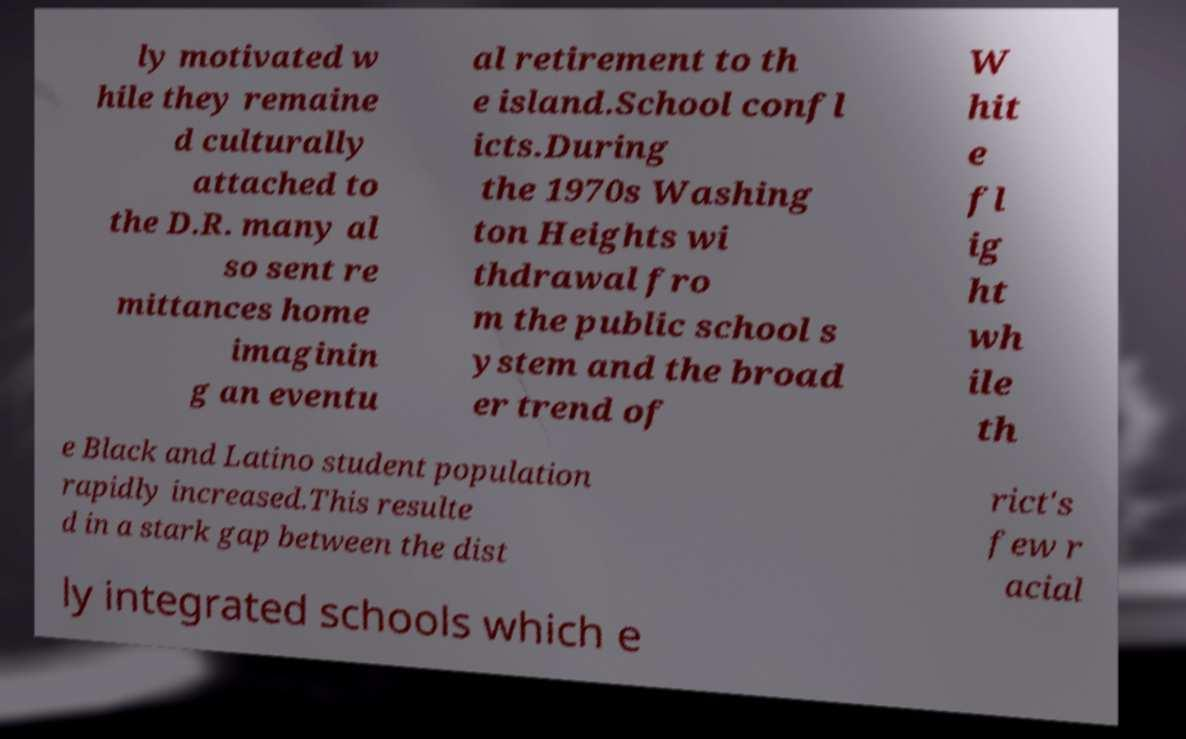There's text embedded in this image that I need extracted. Can you transcribe it verbatim? ly motivated w hile they remaine d culturally attached to the D.R. many al so sent re mittances home imaginin g an eventu al retirement to th e island.School confl icts.During the 1970s Washing ton Heights wi thdrawal fro m the public school s ystem and the broad er trend of W hit e fl ig ht wh ile th e Black and Latino student population rapidly increased.This resulte d in a stark gap between the dist rict's few r acial ly integrated schools which e 